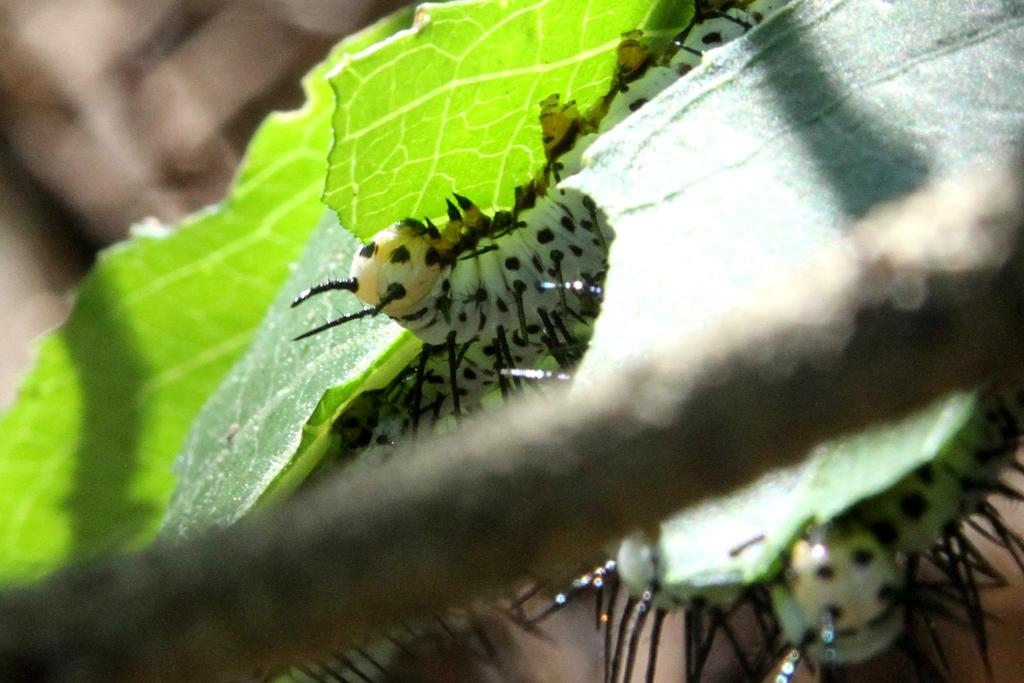What type of creatures can be seen on the leaves in the image? There are insects on the leaves in the image. Can you describe the background of the image? The background of the image is blurred. What type of development can be seen in the image? There is no development visible in the image; it primarily features insects on leaves and a blurred background. 